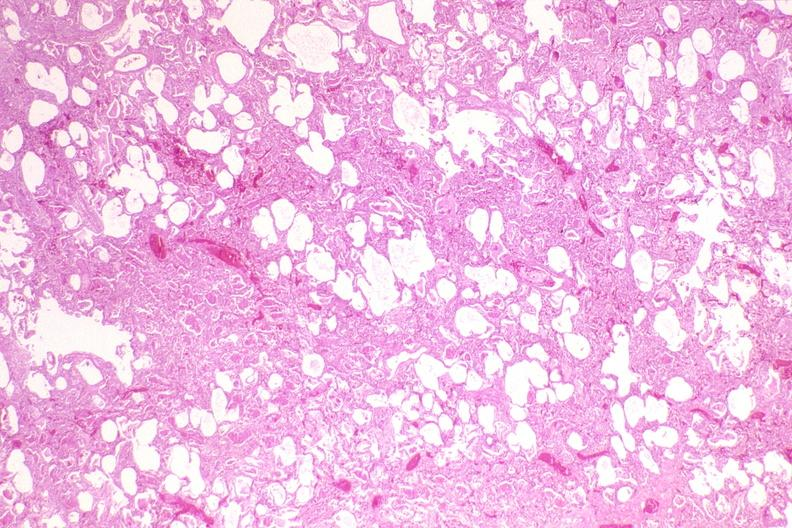where is this?
Answer the question using a single word or phrase. Lung 